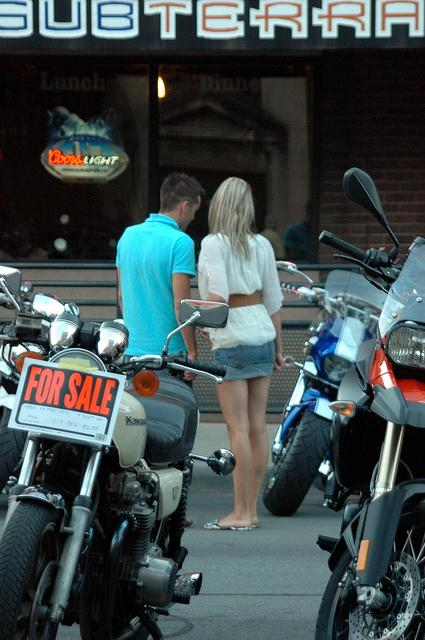What kind of shop is shown in the background?

Choices:
A) car dealer
B) department store
C) bar
D) grocery store bar 